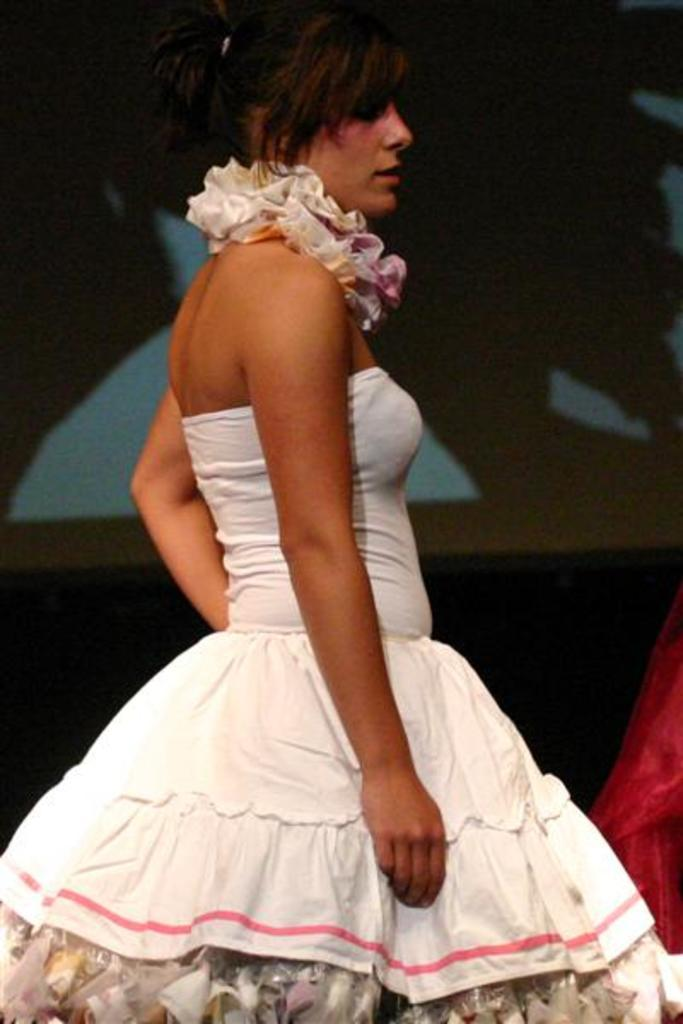What is the main subject of the image? There is a woman standing in the image. What is the woman wearing? The woman is wearing a white dress. What can be observed about the background of the image? The background of the image is dark. What type of poison is the woman holding in the image? There is no poison present in the image; the woman is simply standing and wearing a white dress. What musical instrument is the woman playing in the image? There is no musical instrument present in the image; the woman is just standing and wearing a white dress. 